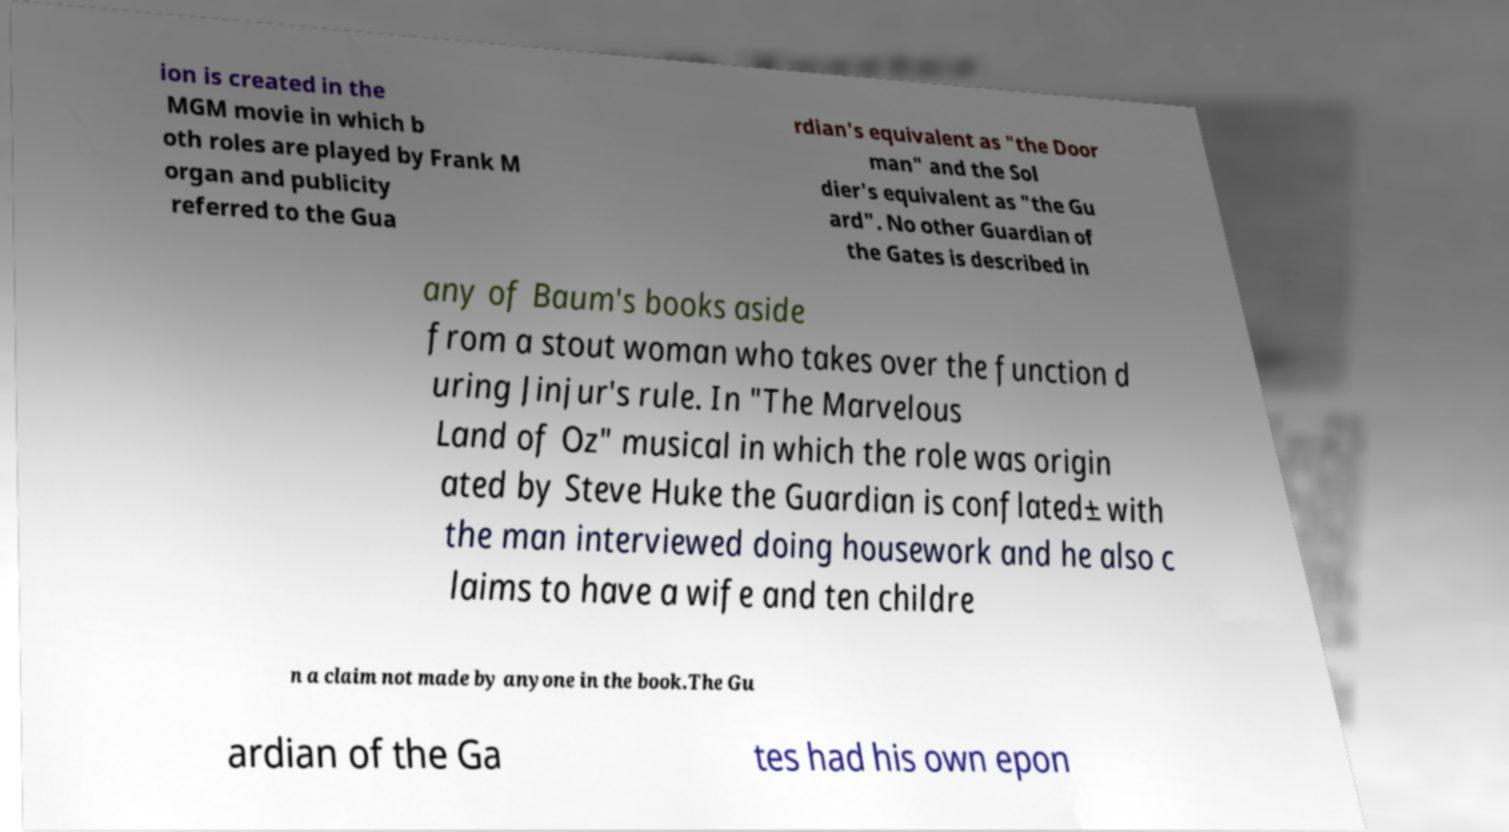There's text embedded in this image that I need extracted. Can you transcribe it verbatim? ion is created in the MGM movie in which b oth roles are played by Frank M organ and publicity referred to the Gua rdian's equivalent as "the Door man" and the Sol dier's equivalent as "the Gu ard". No other Guardian of the Gates is described in any of Baum's books aside from a stout woman who takes over the function d uring Jinjur's rule. In "The Marvelous Land of Oz" musical in which the role was origin ated by Steve Huke the Guardian is conflated± with the man interviewed doing housework and he also c laims to have a wife and ten childre n a claim not made by anyone in the book.The Gu ardian of the Ga tes had his own epon 